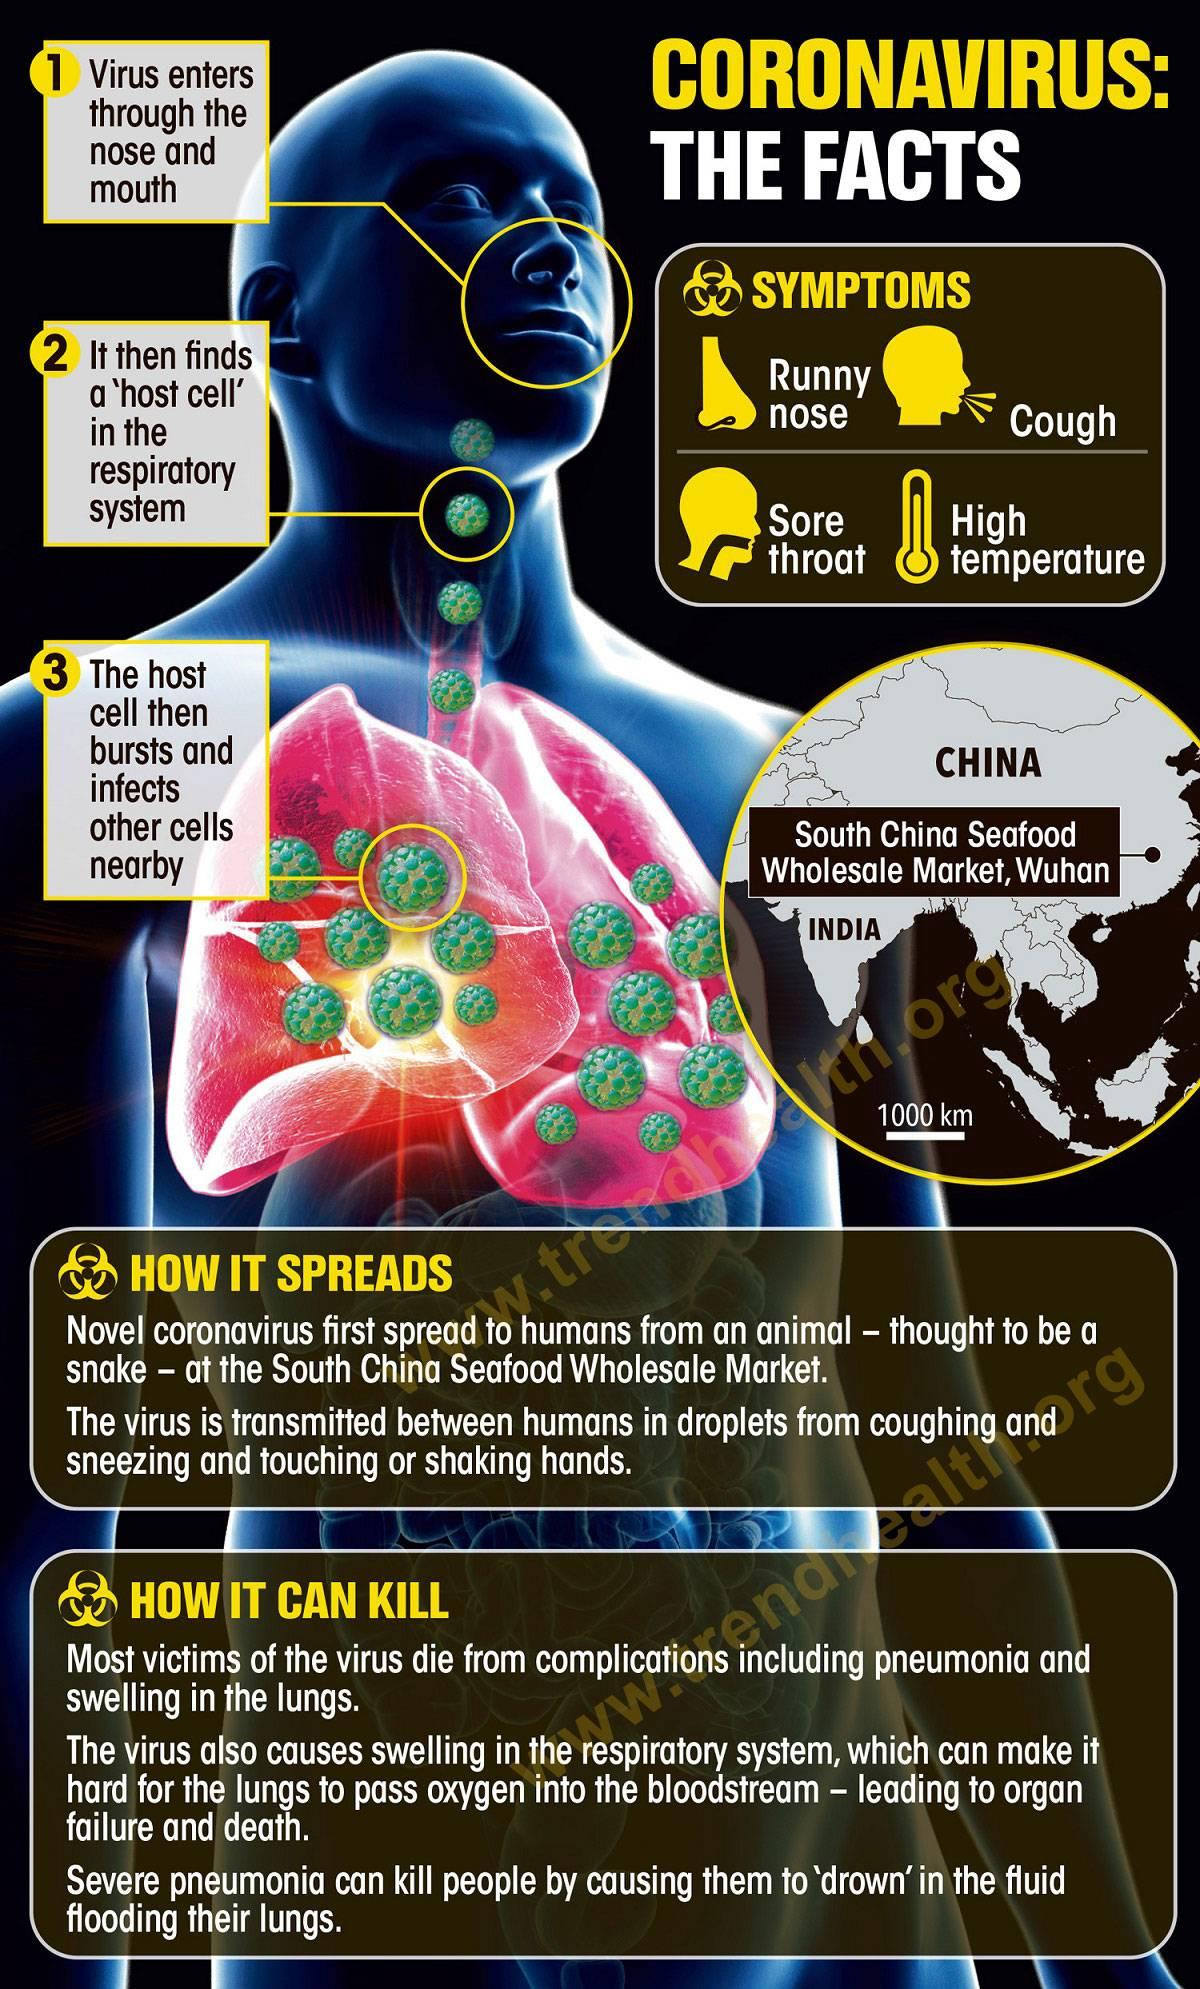Identify some key points in this picture. The infographic contains four symptoms. 